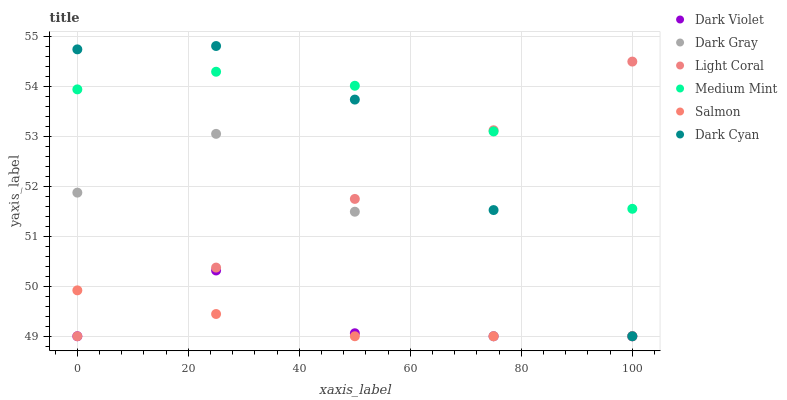Does Salmon have the minimum area under the curve?
Answer yes or no. Yes. Does Medium Mint have the maximum area under the curve?
Answer yes or no. Yes. Does Light Coral have the minimum area under the curve?
Answer yes or no. No. Does Light Coral have the maximum area under the curve?
Answer yes or no. No. Is Light Coral the smoothest?
Answer yes or no. Yes. Is Dark Gray the roughest?
Answer yes or no. Yes. Is Salmon the smoothest?
Answer yes or no. No. Is Salmon the roughest?
Answer yes or no. No. Does Light Coral have the lowest value?
Answer yes or no. Yes. Does Dark Cyan have the highest value?
Answer yes or no. Yes. Does Light Coral have the highest value?
Answer yes or no. No. Is Salmon less than Medium Mint?
Answer yes or no. Yes. Is Medium Mint greater than Salmon?
Answer yes or no. Yes. Does Dark Gray intersect Salmon?
Answer yes or no. Yes. Is Dark Gray less than Salmon?
Answer yes or no. No. Is Dark Gray greater than Salmon?
Answer yes or no. No. Does Salmon intersect Medium Mint?
Answer yes or no. No. 